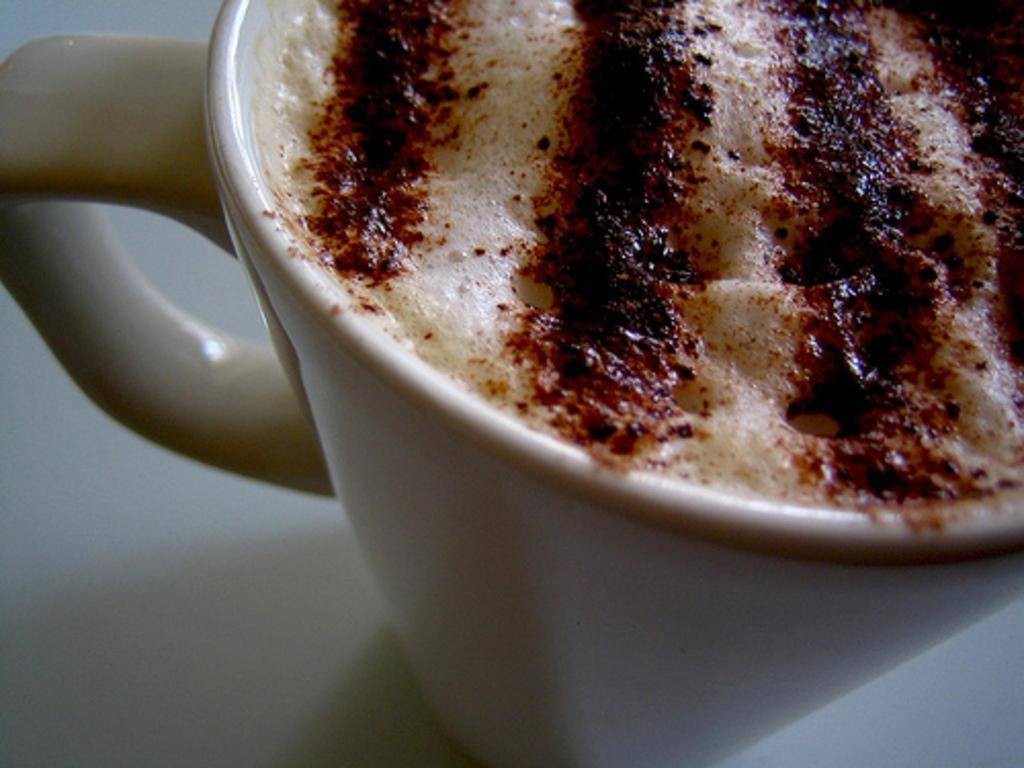What type of beverage is in the image? There is a cappuccino in the image. In what type of container is the cappuccino placed? The cappuccino is in a coffee cup. What baseball team is mentioned in the story on the cup? There is no baseball team or story mentioned on the cup; it only contains a cappuccino. 